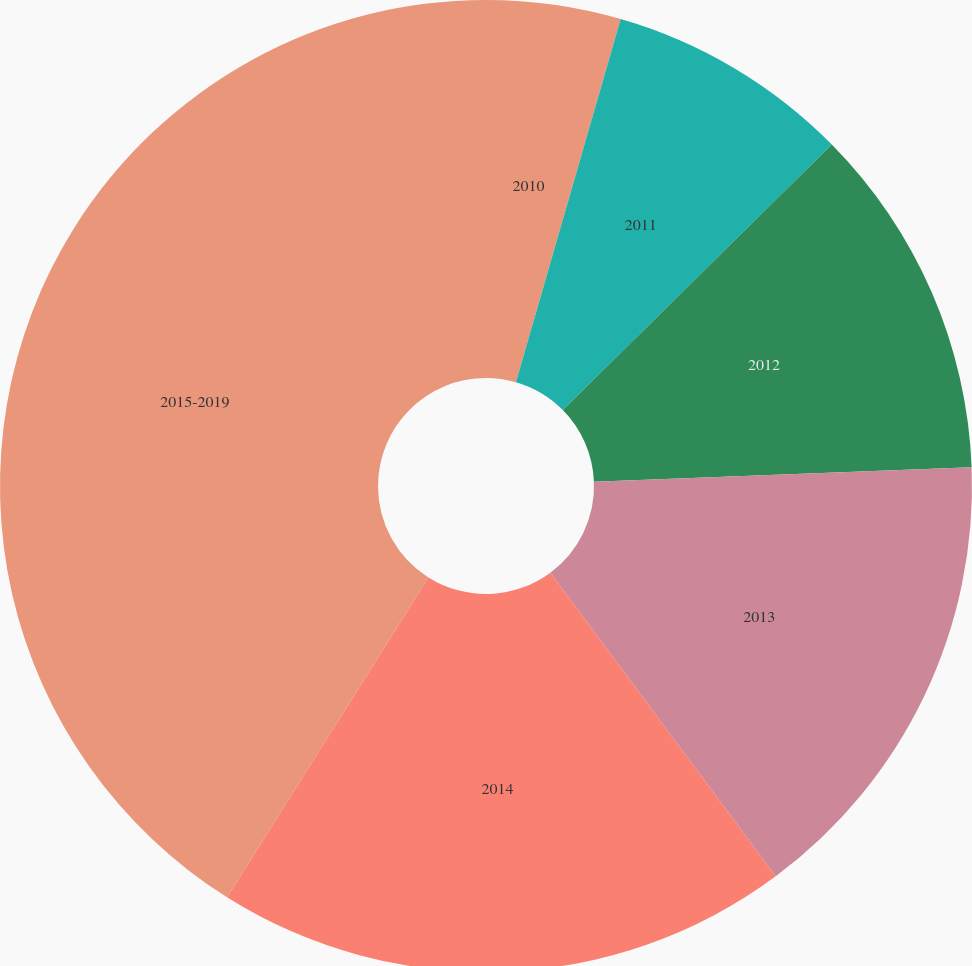Convert chart to OTSL. <chart><loc_0><loc_0><loc_500><loc_500><pie_chart><fcel>2010<fcel>2011<fcel>2012<fcel>2013<fcel>2014<fcel>2015-2019<nl><fcel>4.47%<fcel>8.13%<fcel>11.79%<fcel>15.45%<fcel>19.11%<fcel>41.06%<nl></chart> 